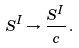Convert formula to latex. <formula><loc_0><loc_0><loc_500><loc_500>S ^ { I } \rightarrow \frac { S ^ { I } } { c } \, .</formula> 